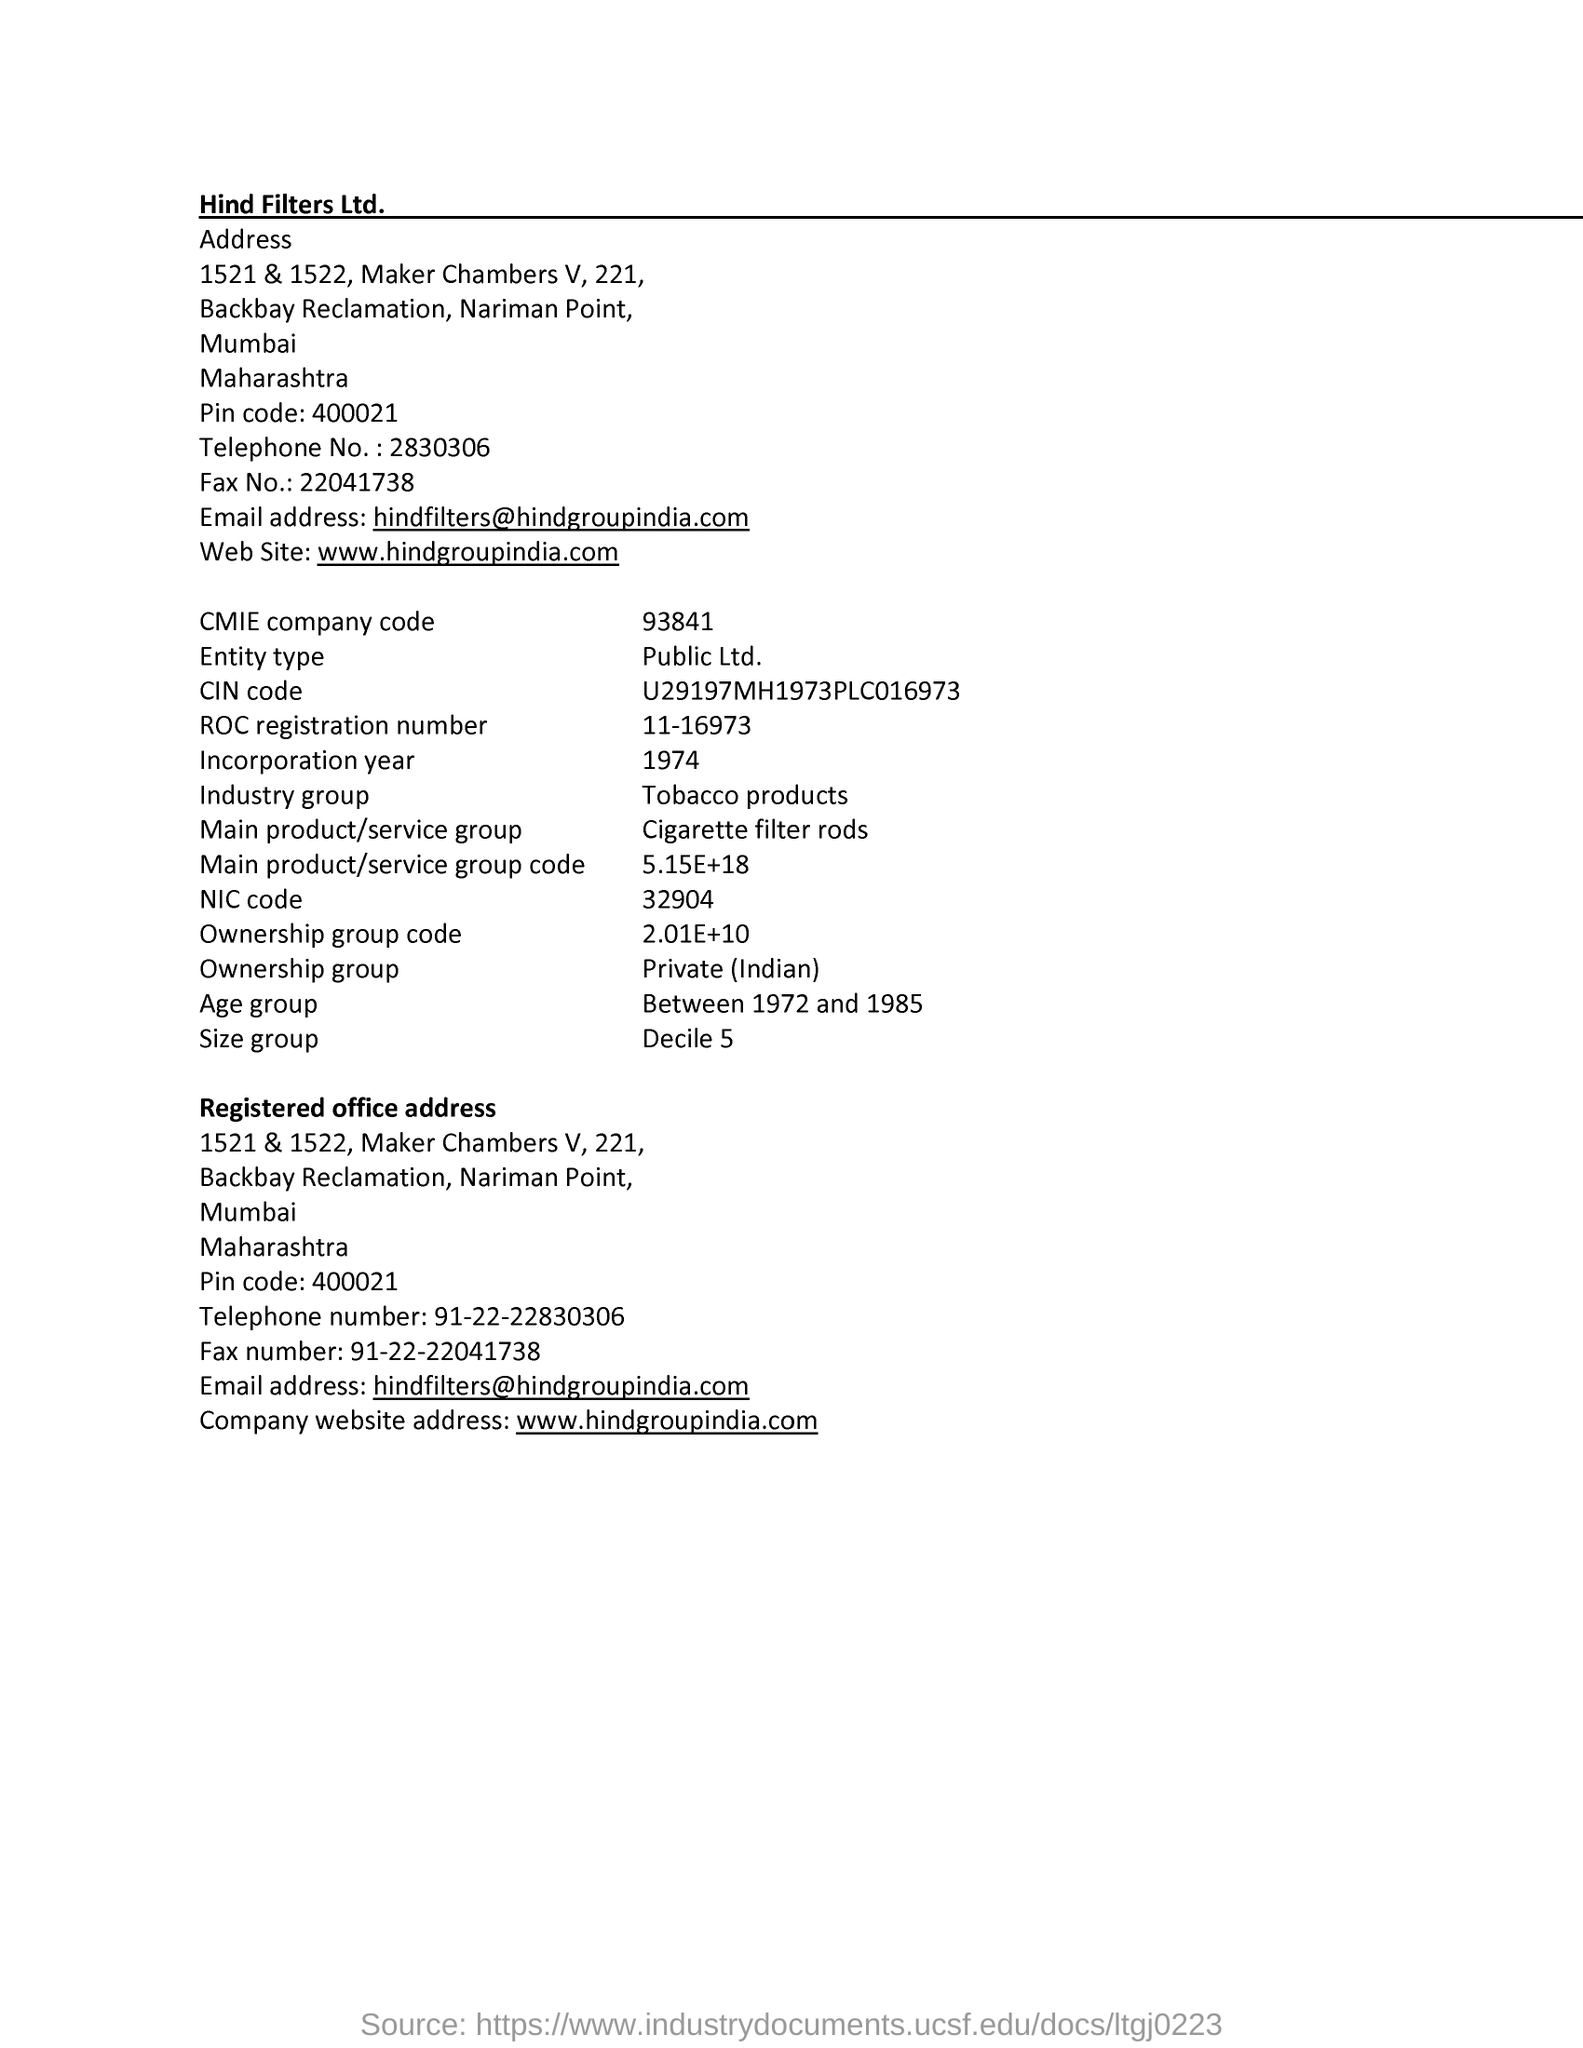Give some essential details in this illustration. The telephone number is 2830306... The NIC code for 32904 is... What is size group? It refers to the tenth decile of a data set, specifically decile 5. The incorporation year is 1974. The company name is Hind Filters Ltd.. 